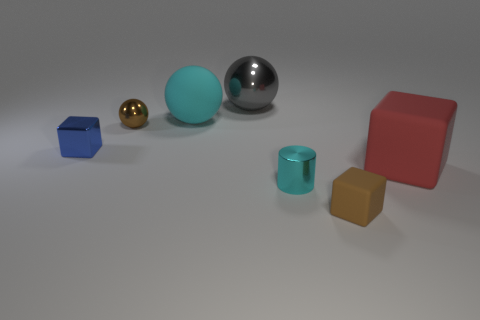Add 3 small cyan shiny cylinders. How many objects exist? 10 Subtract all cubes. How many objects are left? 4 Subtract 0 green blocks. How many objects are left? 7 Subtract all small gray shiny things. Subtract all brown matte things. How many objects are left? 6 Add 5 big shiny things. How many big shiny things are left? 6 Add 4 small red metallic cubes. How many small red metallic cubes exist? 4 